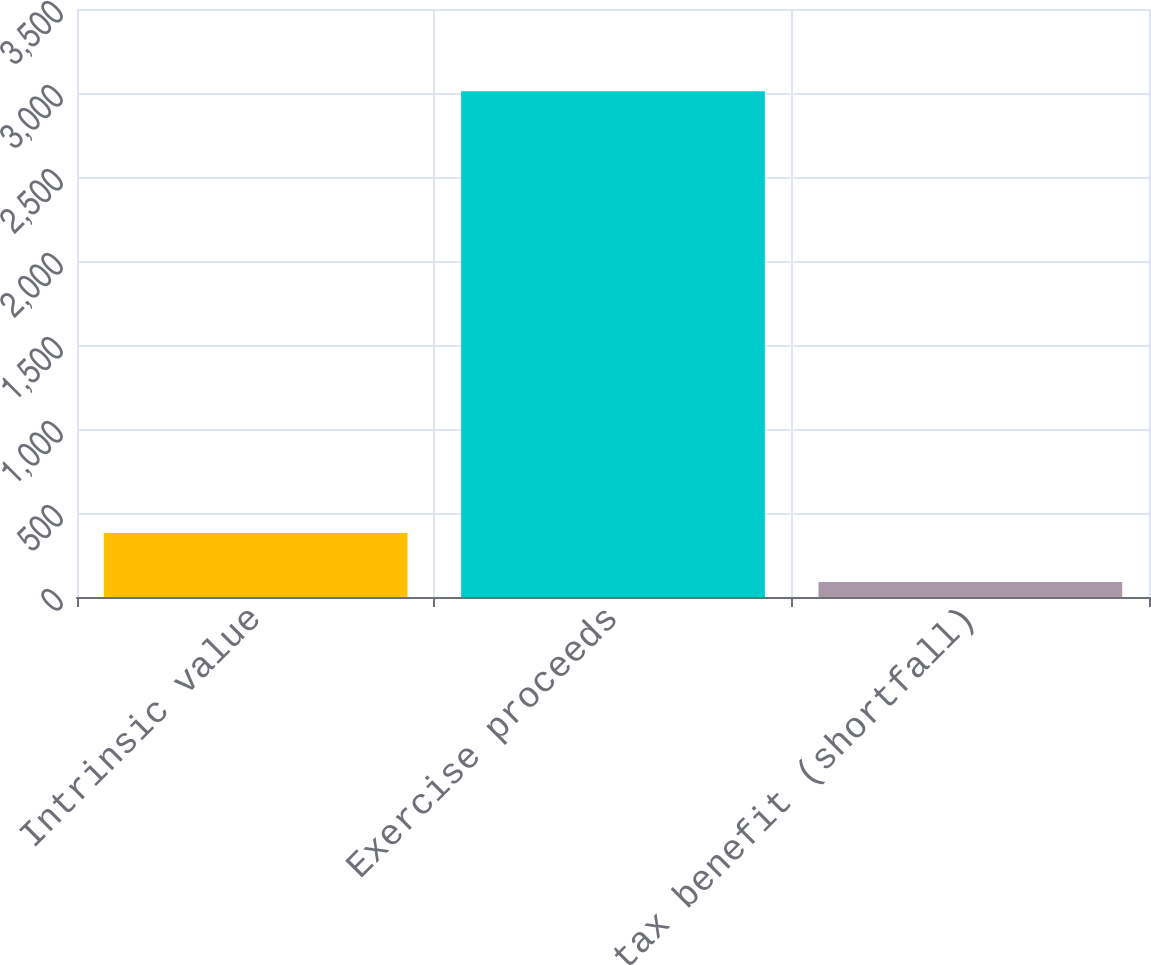Convert chart. <chart><loc_0><loc_0><loc_500><loc_500><bar_chart><fcel>Intrinsic value<fcel>Exercise proceeds<fcel>Income tax benefit (shortfall)<nl><fcel>381.1<fcel>3010<fcel>89<nl></chart> 